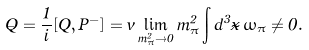<formula> <loc_0><loc_0><loc_500><loc_500>\dot { Q } = \frac { 1 } { i } [ Q , P ^ { - } ] = v \lim _ { m _ { \pi } ^ { 2 } \rightarrow 0 } m _ { \pi } ^ { 2 } \int d ^ { 3 } \vec { x } \, \omega _ { \pi } \neq 0 .</formula> 